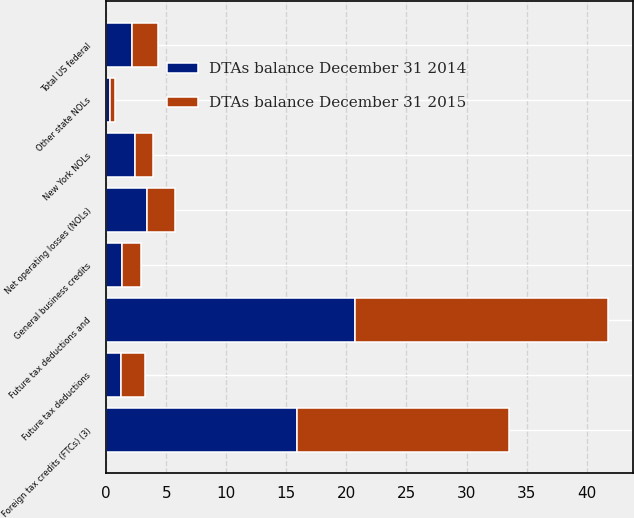<chart> <loc_0><loc_0><loc_500><loc_500><stacked_bar_chart><ecel><fcel>Net operating losses (NOLs)<fcel>Foreign tax credits (FTCs) (3)<fcel>General business credits<fcel>Future tax deductions and<fcel>Total US federal<fcel>New York NOLs<fcel>Other state NOLs<fcel>Future tax deductions<nl><fcel>DTAs balance December 31 2014<fcel>3.4<fcel>15.9<fcel>1.3<fcel>20.7<fcel>2.15<fcel>2.4<fcel>0.3<fcel>1.2<nl><fcel>DTAs balance December 31 2015<fcel>2.3<fcel>17.6<fcel>1.6<fcel>21.1<fcel>2.15<fcel>1.5<fcel>0.4<fcel>2<nl></chart> 